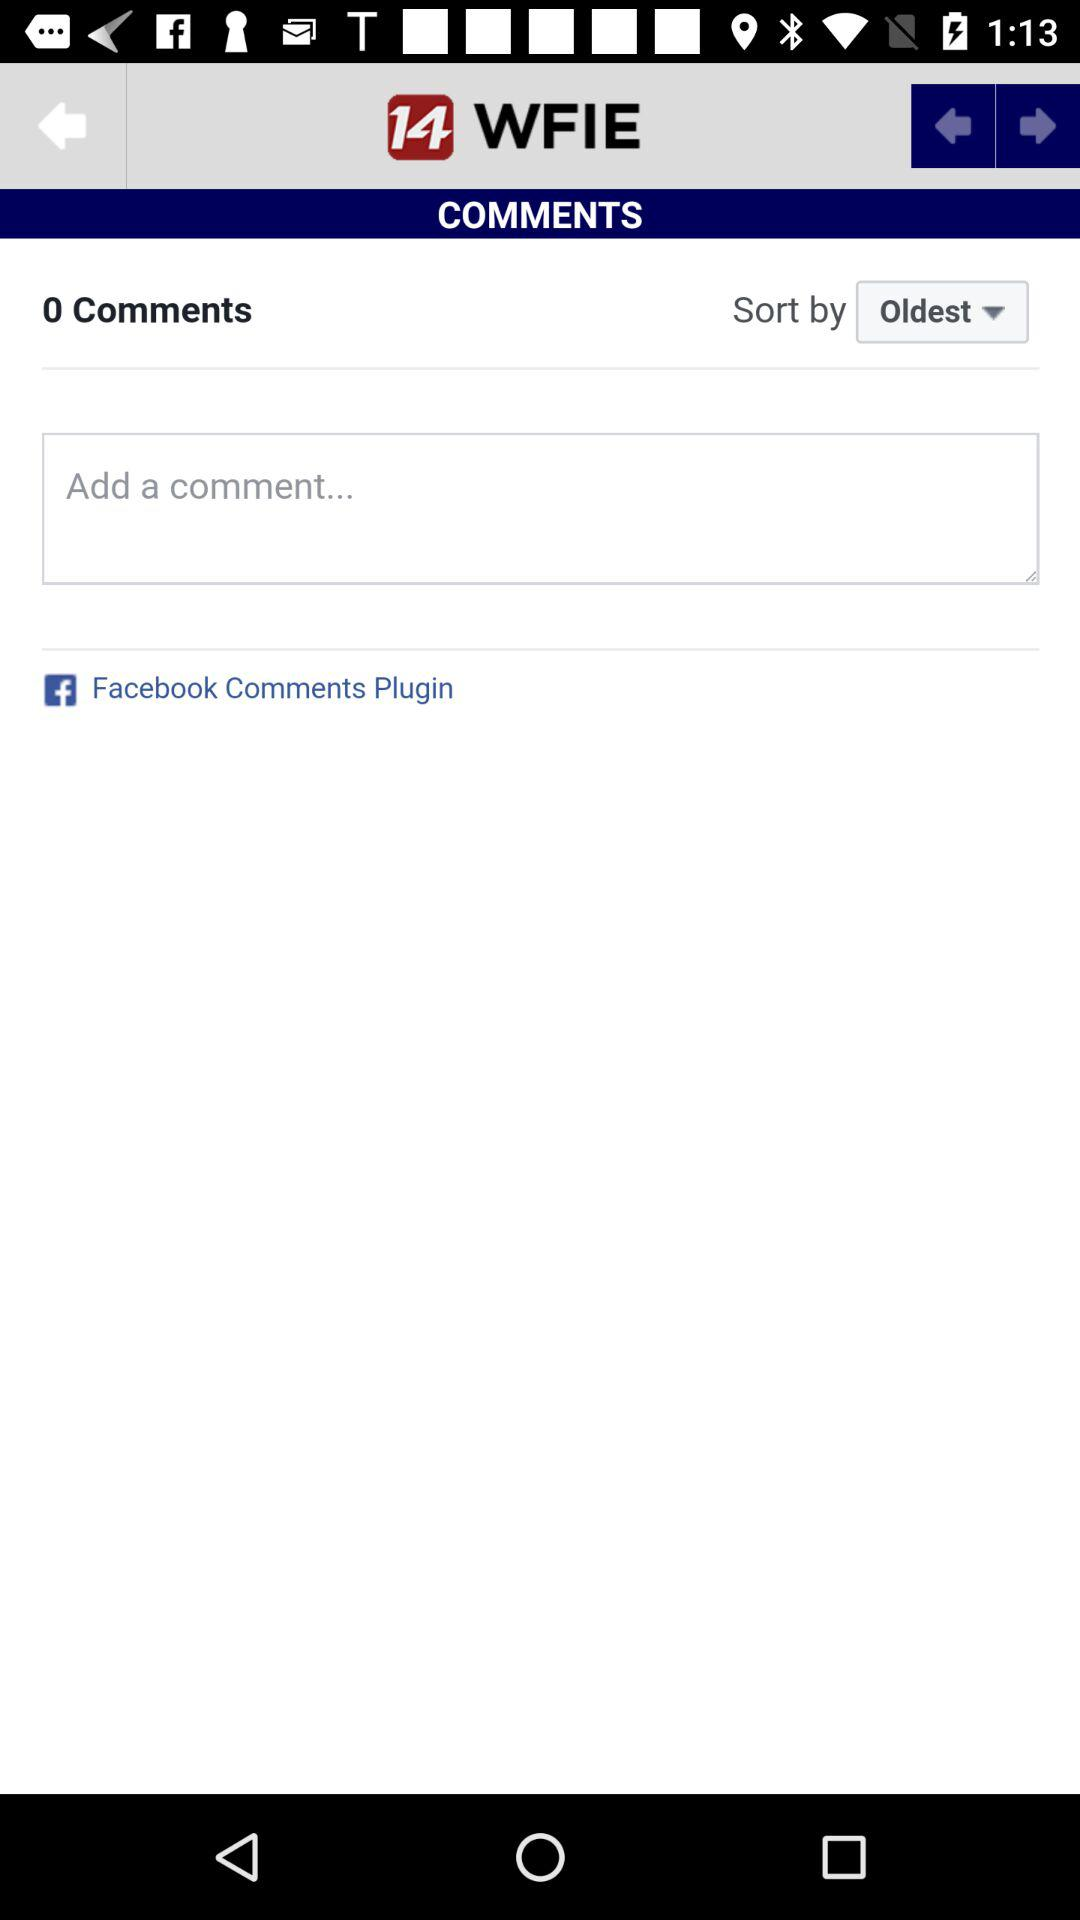What is the name of the application? The name of the application is "14 WFIE". 